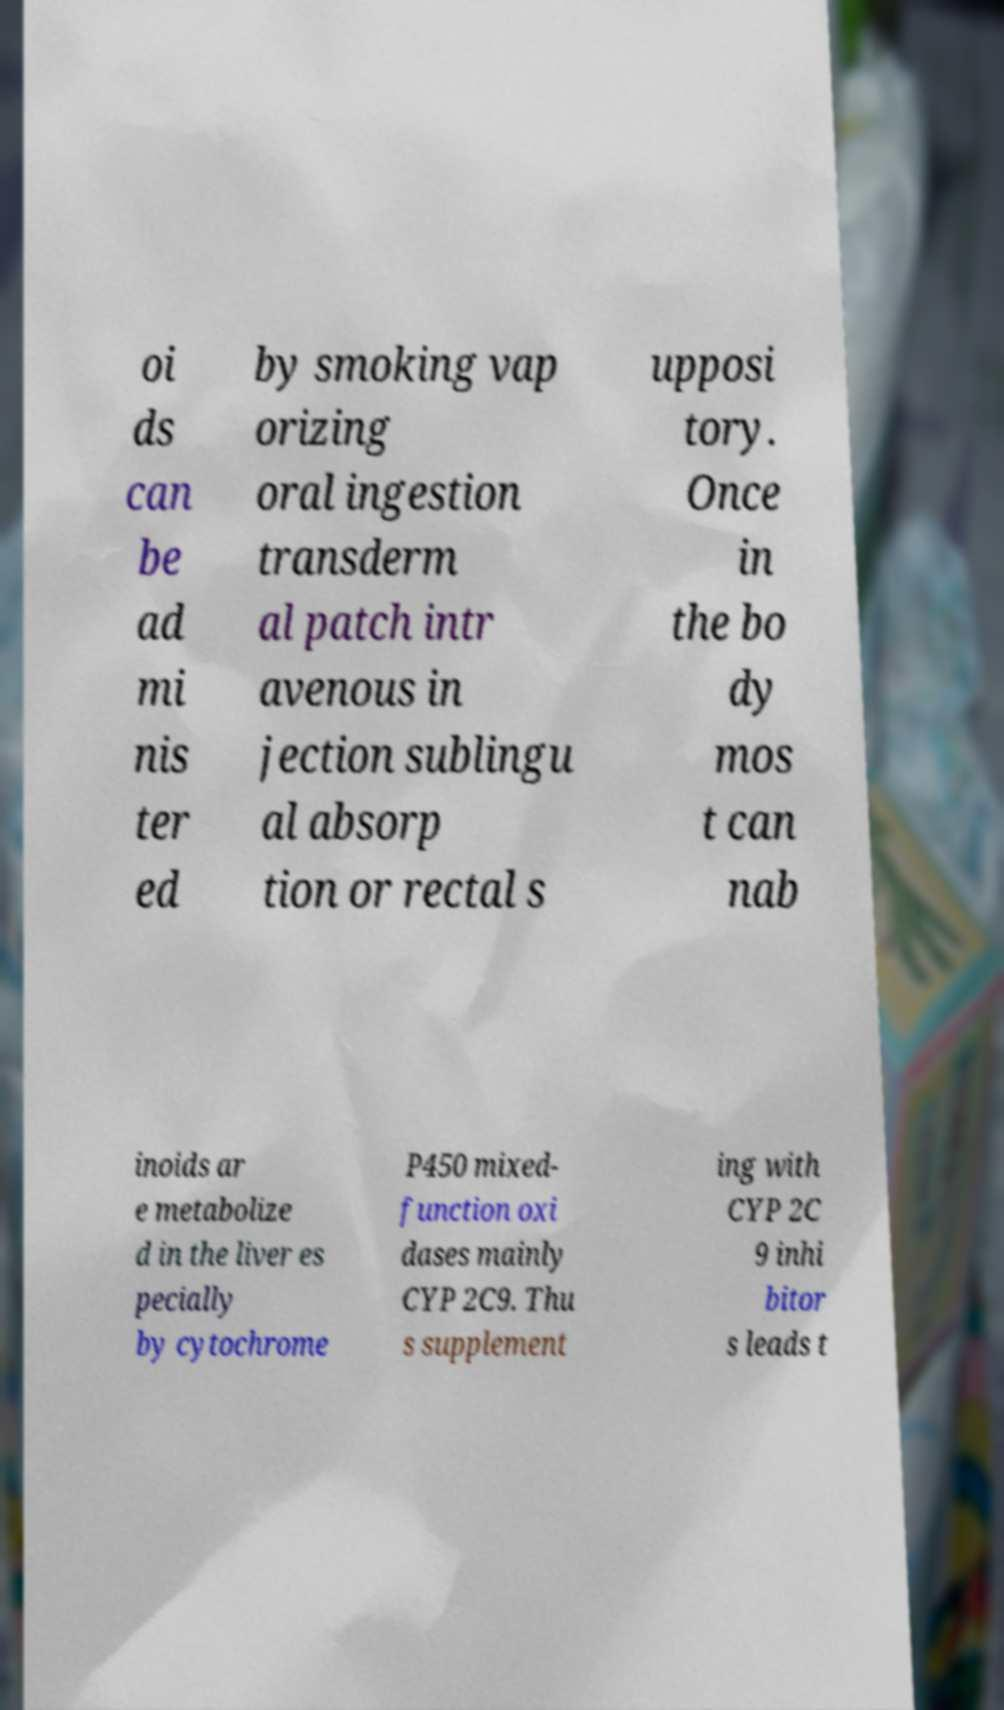Could you assist in decoding the text presented in this image and type it out clearly? oi ds can be ad mi nis ter ed by smoking vap orizing oral ingestion transderm al patch intr avenous in jection sublingu al absorp tion or rectal s upposi tory. Once in the bo dy mos t can nab inoids ar e metabolize d in the liver es pecially by cytochrome P450 mixed- function oxi dases mainly CYP 2C9. Thu s supplement ing with CYP 2C 9 inhi bitor s leads t 